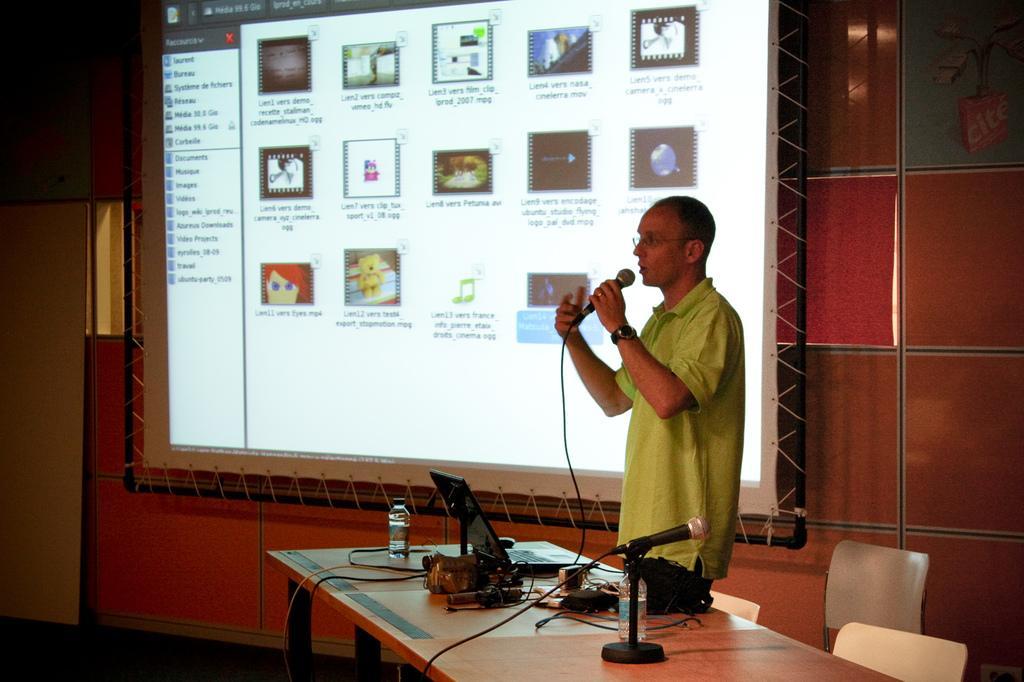Please provide a concise description of this image. The person wearing green T-shirt is standing and speaking in front of a mic and there is a table in front of him which has a mic,a laptop and some other objects on it and there is a projected image beside him. 